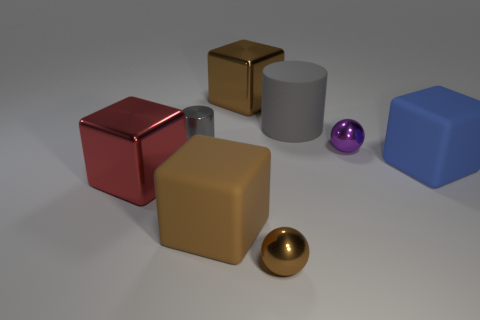Subtract all cyan spheres. How many brown cubes are left? 2 Subtract all big red metal cubes. How many cubes are left? 3 Subtract 1 cubes. How many cubes are left? 3 Add 1 tiny brown cylinders. How many objects exist? 9 Subtract all red blocks. How many blocks are left? 3 Subtract all cylinders. How many objects are left? 6 Subtract all blue cubes. Subtract all brown cylinders. How many cubes are left? 3 Subtract all tiny spheres. Subtract all tiny metallic balls. How many objects are left? 4 Add 2 large metal blocks. How many large metal blocks are left? 4 Add 4 tiny brown metallic balls. How many tiny brown metallic balls exist? 5 